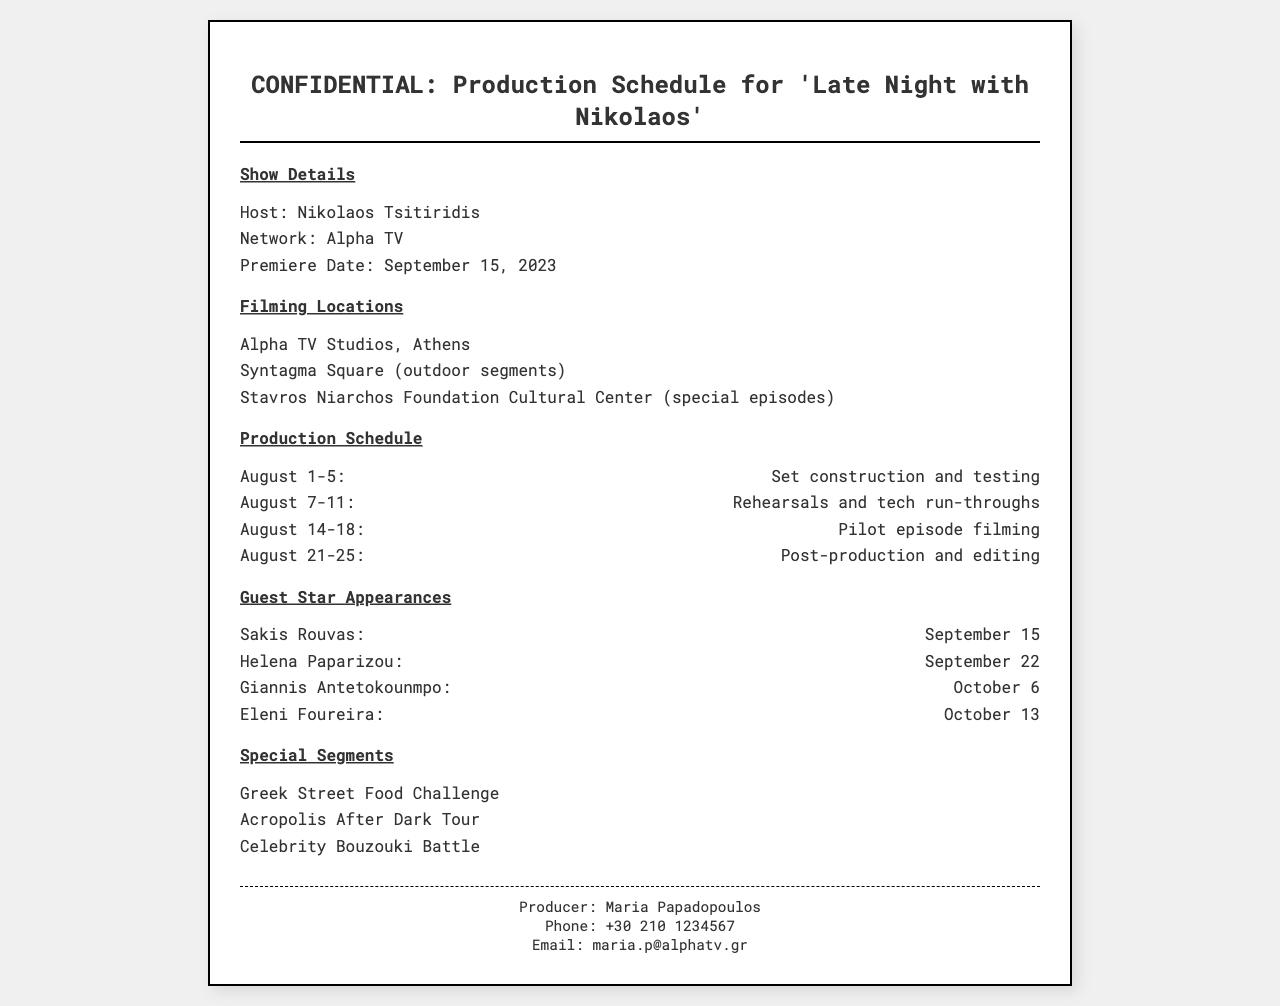What is the host's name? The host's name is mentioned in the show details section of the document.
Answer: Nikolaos Tsitiridis What is the premiere date? The premiere date is provided in the show details section of the document.
Answer: September 15, 2023 How many locations are listed for filming? The document lists three locations for filming in the filming locations section.
Answer: 3 What is the date for the pilot episode filming? The pilot episode filming date is stated in the production schedule section.
Answer: August 14-18 Who is the guest star appearing on September 22? The document specifies who appears on September 22 in the guest star appearances section.
Answer: Helena Paparizou What segment involves food? The special segments section contains information about segments, one of which involves food.
Answer: Greek Street Food Challenge What is the name of the producer? The name of the producer is mentioned at the bottom of the document.
Answer: Maria Papadopoulos What is the second filming location? The second filming location is specified in the filming locations section of the document.
Answer: Syntagma Square What is the email contact for the producer? The document provides the email address for the producer in the footer.
Answer: maria.p@alphatv.gr 